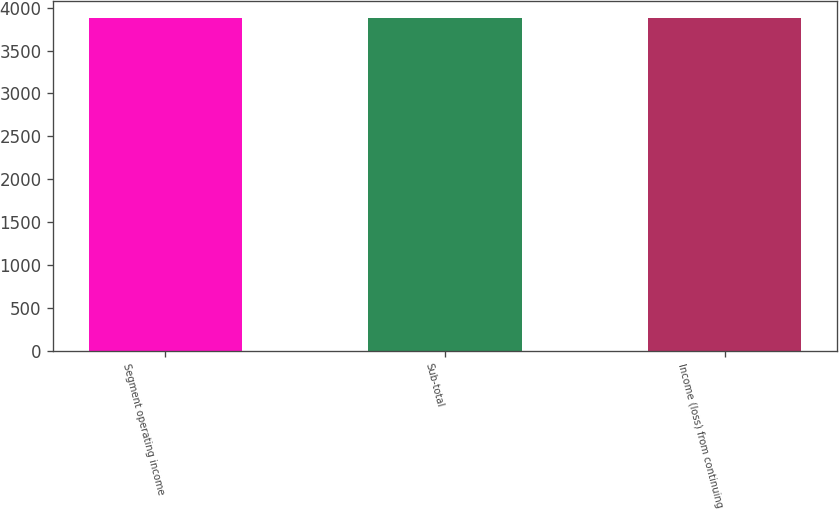Convert chart. <chart><loc_0><loc_0><loc_500><loc_500><bar_chart><fcel>Segment operating income<fcel>Sub-total<fcel>Income (loss) from continuing<nl><fcel>3878<fcel>3878.1<fcel>3878.2<nl></chart> 